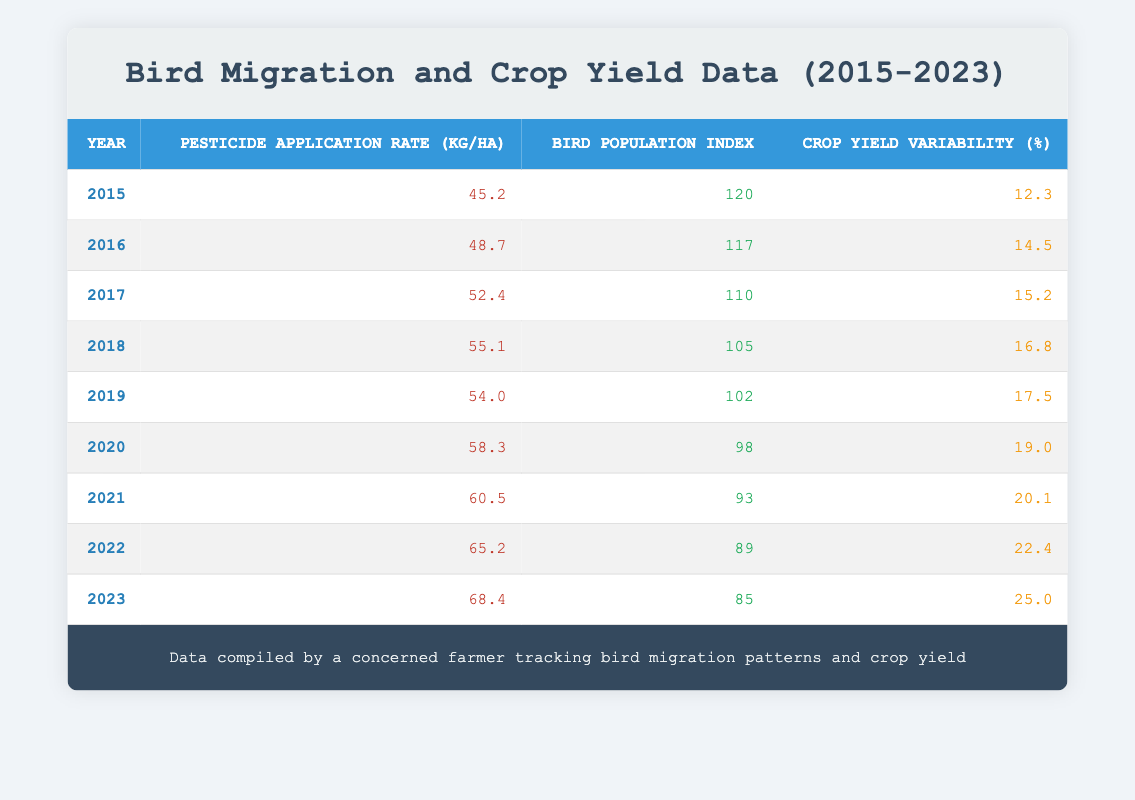What was the pesticide application rate in 2020? The table indicates that in the year 2020, the pesticide application rate was listed as 58.3 kg/ha.
Answer: 58.3 kg/ha What was the bird population index in 2018? According to the table, the bird population index for the year 2018 was recorded as 105.
Answer: 105 Is there a trend showing that pesticide application rates increase over time? By looking at the years from 2015 to 2023, each subsequent year shows a higher pesticide application rate compared to the previous year, confirming a consistent upward trend.
Answer: Yes What is the difference in crop yield variability between 2015 and 2023? To find the difference, subtract the crop yield variability in 2015 (12.3%) from that in 2023 (25.0%). Thus, 25.0 - 12.3 = 12.7.
Answer: 12.7% What was the average bird population index from 2015 to 2023? The bird population indices from 2015 to 2023 are 120, 117, 110, 105, 102, 98, 93, 89, and 85. Adding these values gives 1,019. Since there are 9 years, we divide 1,019 by 9, resulting in an average of approximately 113.22.
Answer: 113.22 Did the crop yield variability ever decrease from one year to the next? Examining the crop yield variability data from each year, it can be observed that each value is higher than the last, indicating that crop yield variability did not decrease from any year to the next.
Answer: No What was the highest pesticide application rate recorded and in which year? The highest pesticide application rate in the table is 68.4 kg/ha, which occurred in the year 2023, making this the maximum recorded value during the timeframe.
Answer: 68.4 kg/ha in 2023 How much did the bird population index decline from 2015 to 2021? The bird population index in 2015 was 120, and in 2021 it was 93. The decline is calculated as 120 - 93, which equals a total drop of 27.
Answer: 27 What is the relationship between pesticide application rate and crop yield variability over the years? Observing the data, as the pesticide application rates increase over the years, the crop yield variability also increases correspondingly. This suggests a positive correlation between the two variables during the observed period.
Answer: Positive correlation 